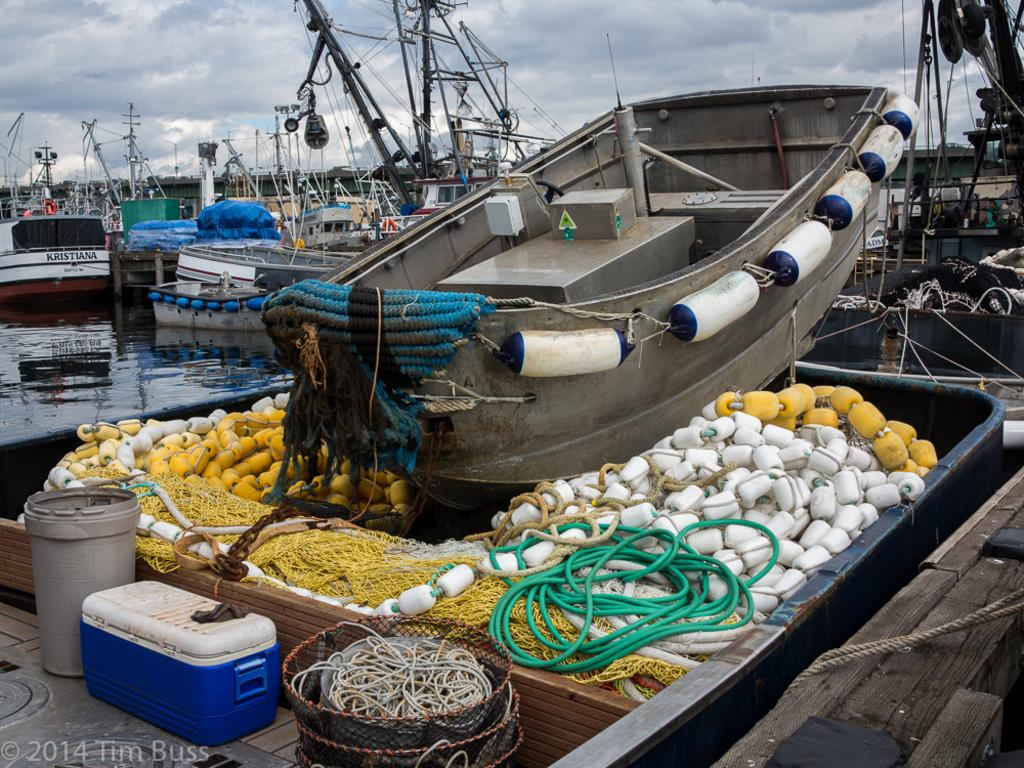What type of vehicles can be seen in the image? There are boats in the image. What is the purpose of the bucket in the image? The purpose of the bucket is not specified, but it is present in the image. What is the purpose of the box in the image? The purpose of the box is not specified, but it is present in the image. What are the ropes used for in the image? The purpose of the ropes is not specified, but they are present in the image. What can be seen in the background of the image? The sky in the background is a combination of white and blue colors. What type of meat is being prepared on the grill in the image? There is no grill or meat present in the image. What knowledge is being shared among the people in the image? There are no people present in the image, and therefore no knowledge is being shared. 